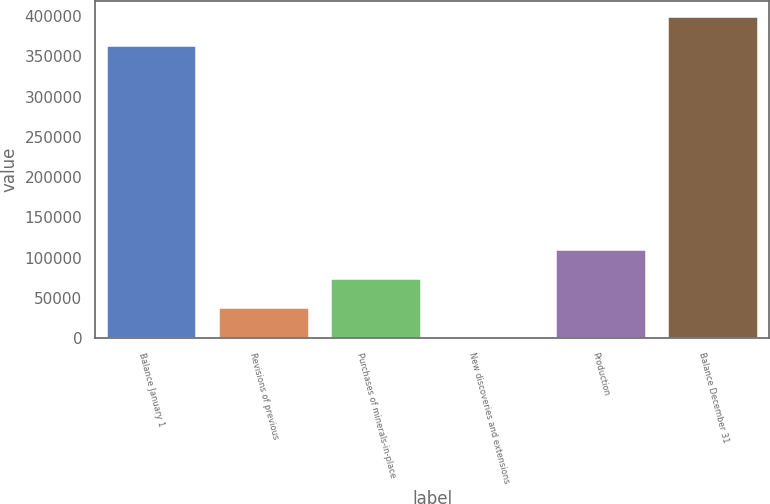<chart> <loc_0><loc_0><loc_500><loc_500><bar_chart><fcel>Balance January 1<fcel>Revisions of previous<fcel>Purchases of minerals-in-place<fcel>New discoveries and extensions<fcel>Production<fcel>Balance December 31<nl><fcel>362751<fcel>37241<fcel>73465<fcel>1017<fcel>109689<fcel>398975<nl></chart> 